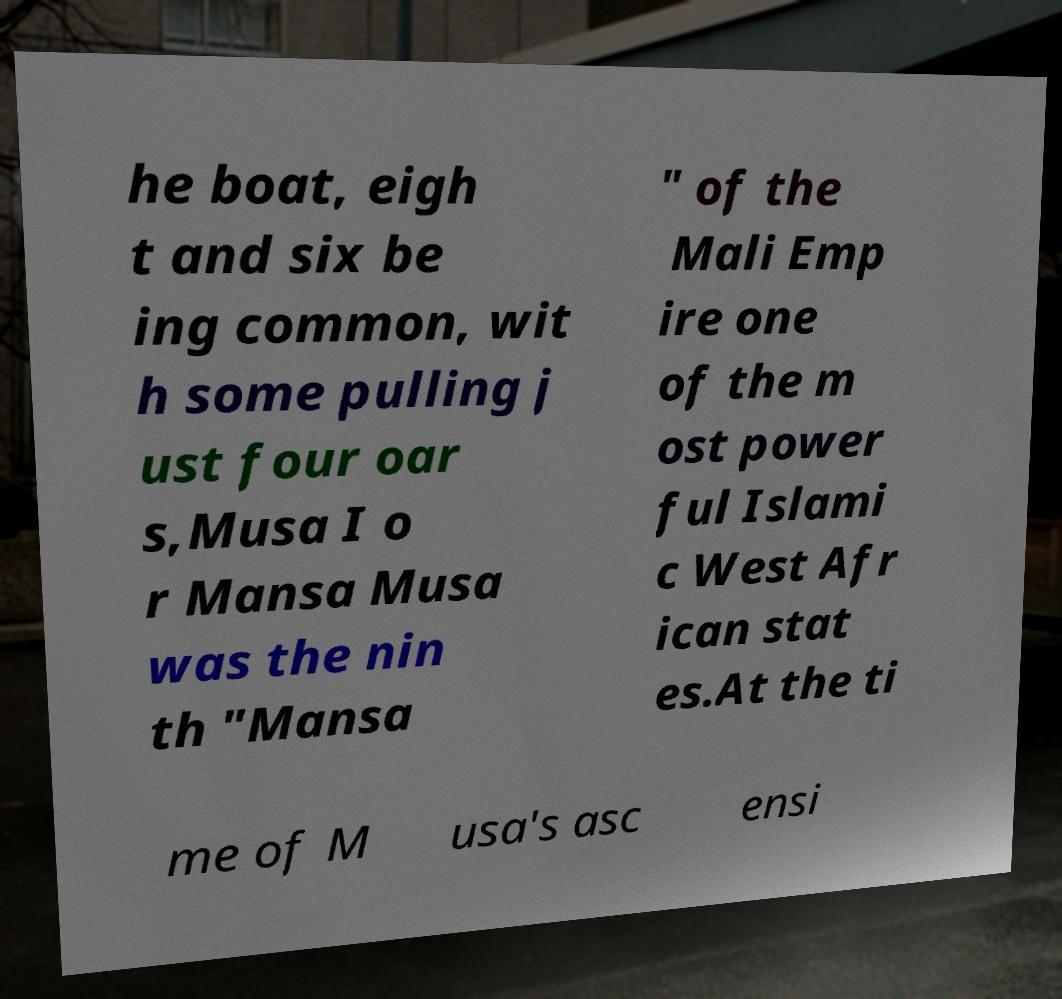Can you accurately transcribe the text from the provided image for me? he boat, eigh t and six be ing common, wit h some pulling j ust four oar s,Musa I o r Mansa Musa was the nin th "Mansa " of the Mali Emp ire one of the m ost power ful Islami c West Afr ican stat es.At the ti me of M usa's asc ensi 